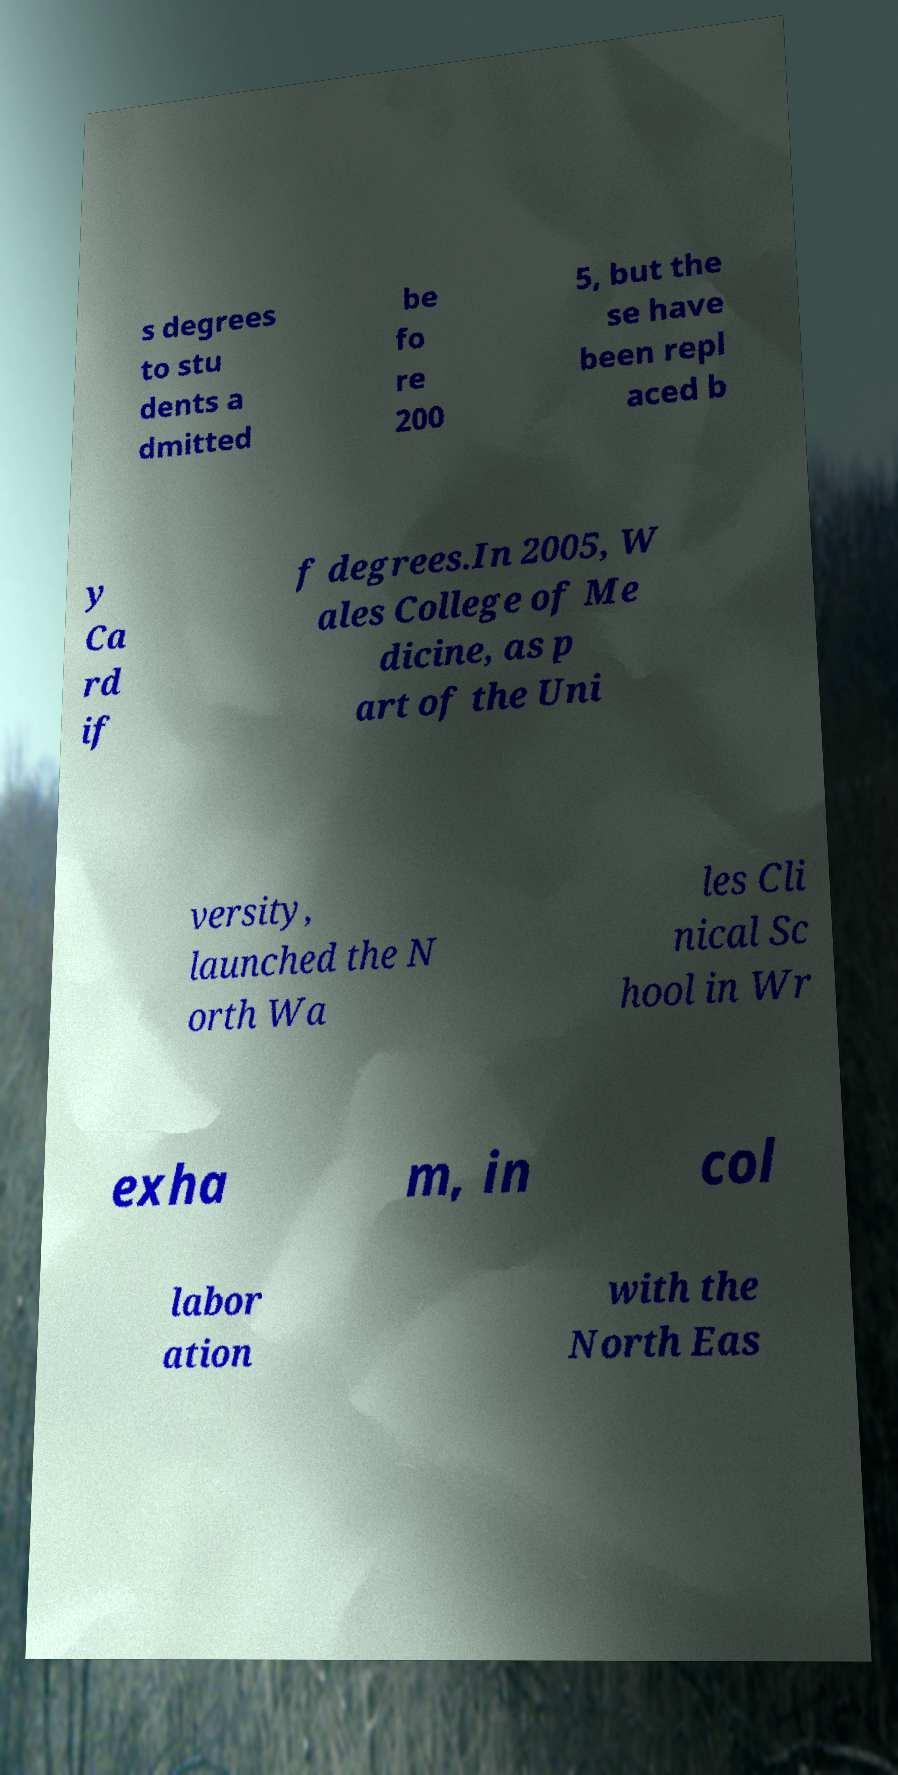There's text embedded in this image that I need extracted. Can you transcribe it verbatim? s degrees to stu dents a dmitted be fo re 200 5, but the se have been repl aced b y Ca rd if f degrees.In 2005, W ales College of Me dicine, as p art of the Uni versity, launched the N orth Wa les Cli nical Sc hool in Wr exha m, in col labor ation with the North Eas 